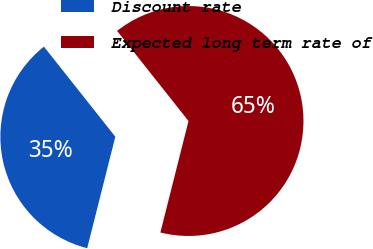Convert chart. <chart><loc_0><loc_0><loc_500><loc_500><pie_chart><fcel>Discount rate<fcel>Expected long term rate of<nl><fcel>35.4%<fcel>64.6%<nl></chart> 